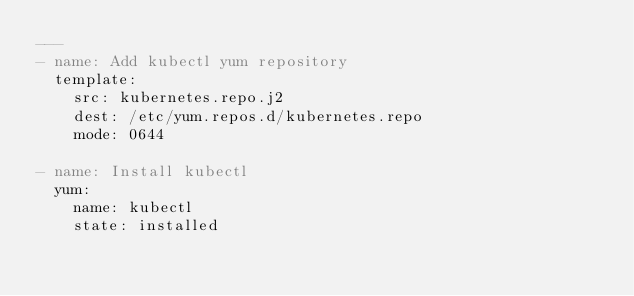<code> <loc_0><loc_0><loc_500><loc_500><_YAML_>---
- name: Add kubectl yum repository
  template:
    src: kubernetes.repo.j2
    dest: /etc/yum.repos.d/kubernetes.repo
    mode: 0644

- name: Install kubectl
  yum:
    name: kubectl
    state: installed</code> 